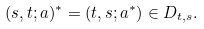Convert formula to latex. <formula><loc_0><loc_0><loc_500><loc_500>( s , t ; a ) ^ { \ast } = ( t , s ; a ^ { \ast } ) \in D _ { t , s } .</formula> 